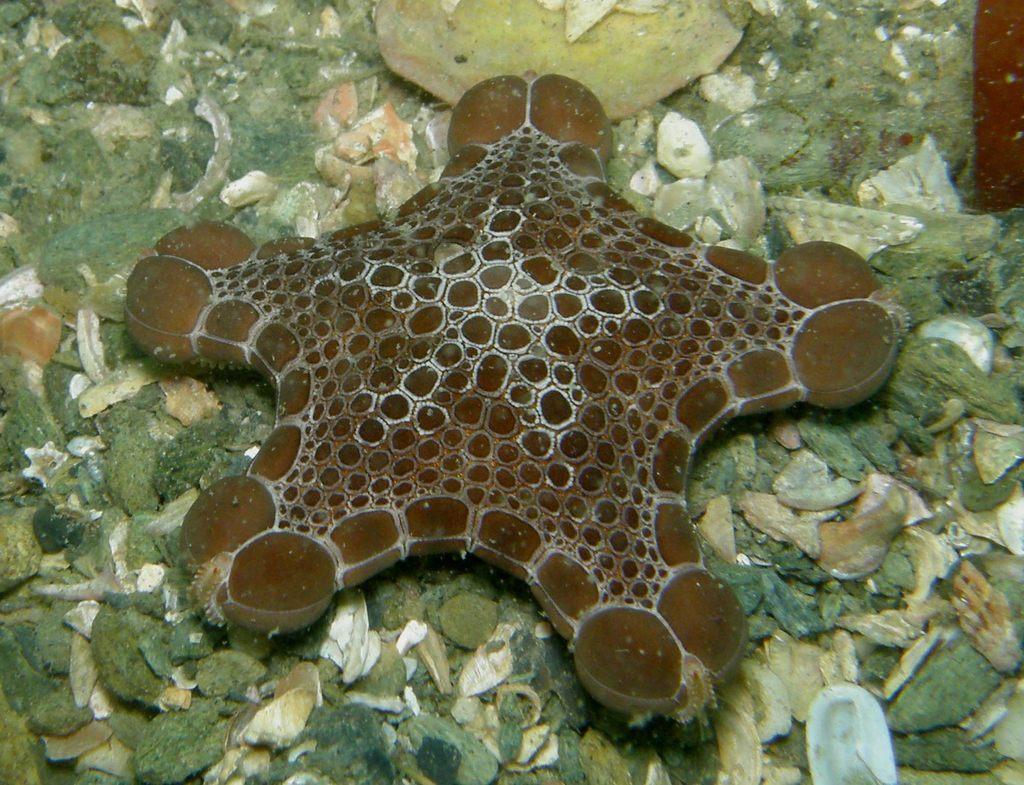In one or two sentences, can you explain what this image depicts? In this image I can see an aquatic animal which is in brown color. In the background I can see many rocks which are in white, brown and ash color. 